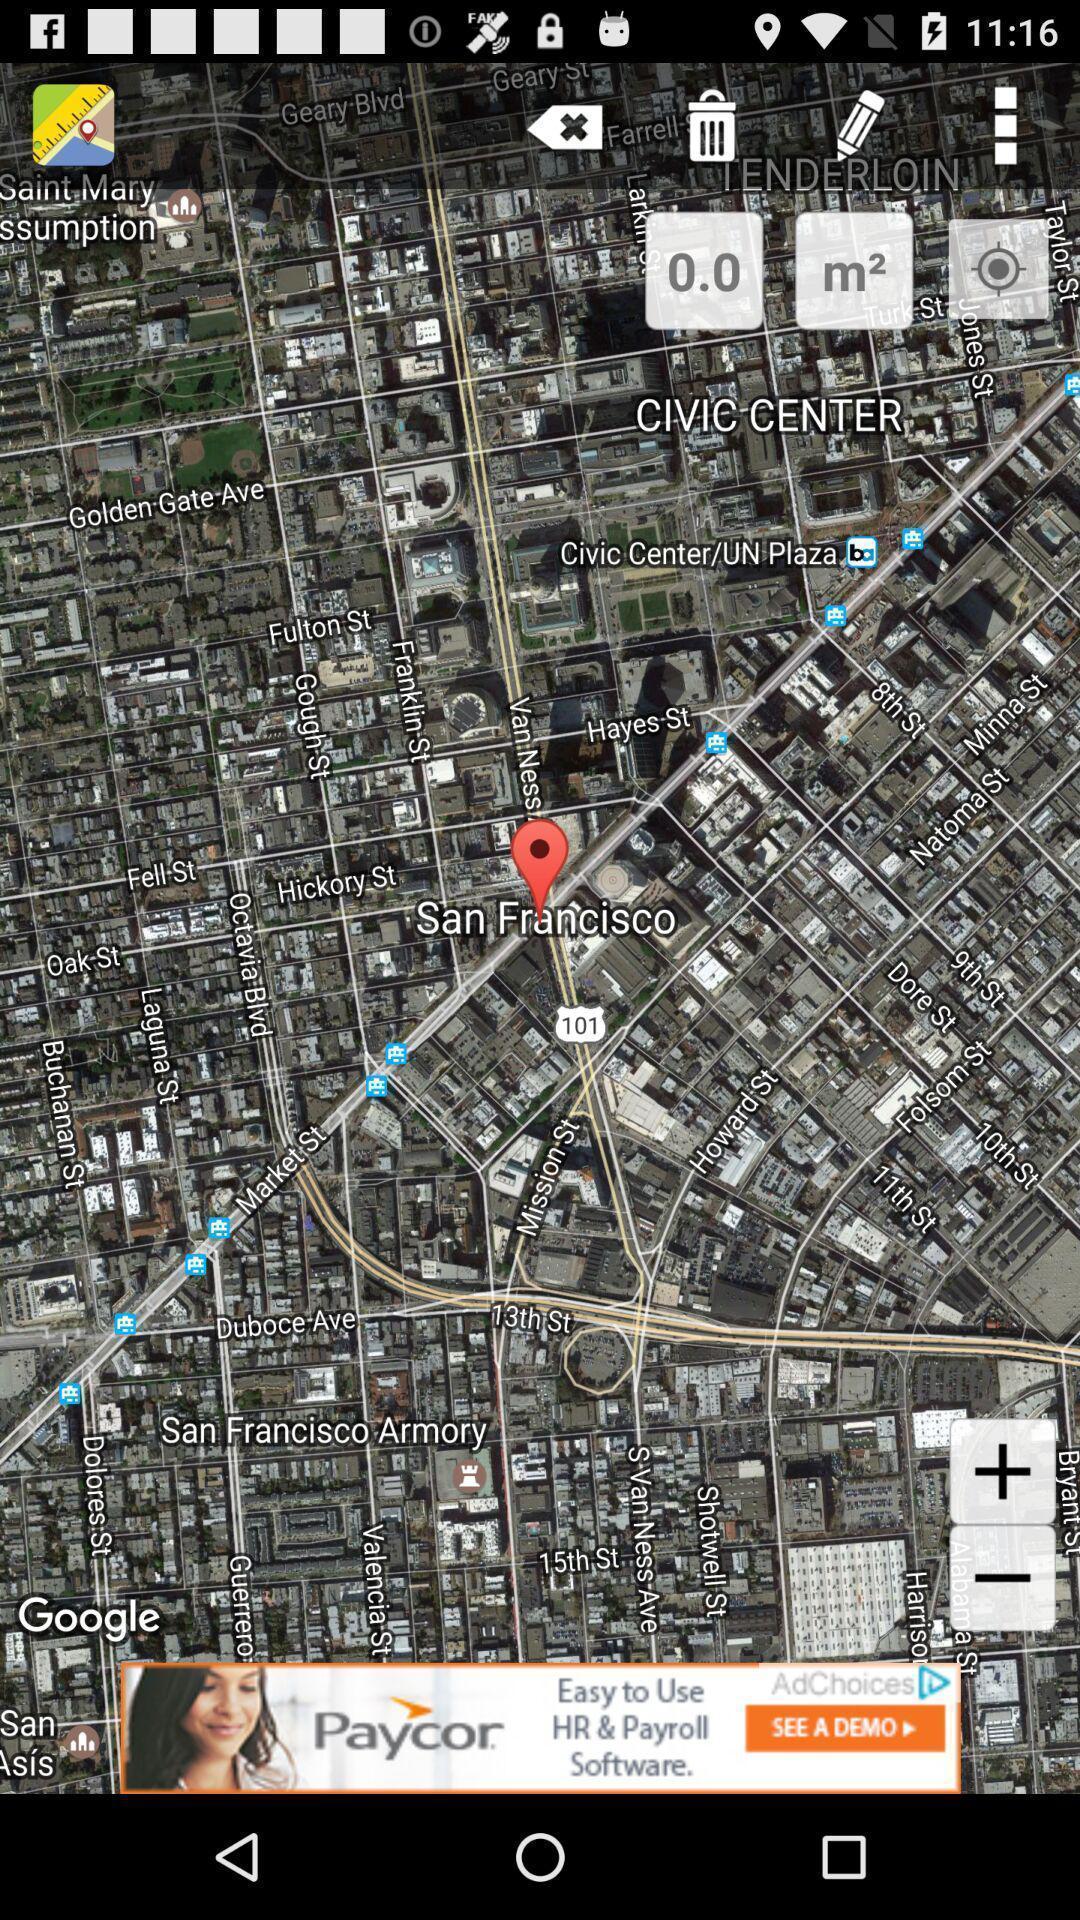Give me a summary of this screen capture. Page displaying the location in navigation app. 